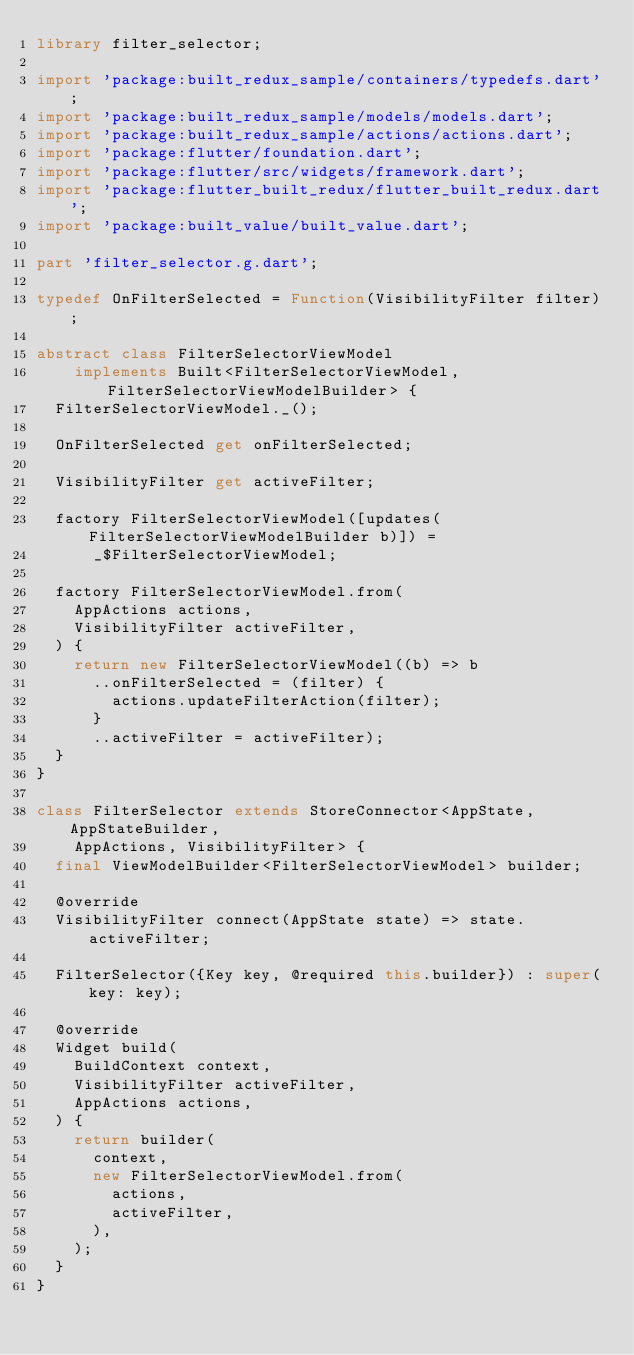<code> <loc_0><loc_0><loc_500><loc_500><_Dart_>library filter_selector;

import 'package:built_redux_sample/containers/typedefs.dart';
import 'package:built_redux_sample/models/models.dart';
import 'package:built_redux_sample/actions/actions.dart';
import 'package:flutter/foundation.dart';
import 'package:flutter/src/widgets/framework.dart';
import 'package:flutter_built_redux/flutter_built_redux.dart';
import 'package:built_value/built_value.dart';

part 'filter_selector.g.dart';

typedef OnFilterSelected = Function(VisibilityFilter filter);

abstract class FilterSelectorViewModel
    implements Built<FilterSelectorViewModel, FilterSelectorViewModelBuilder> {
  FilterSelectorViewModel._();

  OnFilterSelected get onFilterSelected;

  VisibilityFilter get activeFilter;

  factory FilterSelectorViewModel([updates(FilterSelectorViewModelBuilder b)]) =
      _$FilterSelectorViewModel;

  factory FilterSelectorViewModel.from(
    AppActions actions,
    VisibilityFilter activeFilter,
  ) {
    return new FilterSelectorViewModel((b) => b
      ..onFilterSelected = (filter) {
        actions.updateFilterAction(filter);
      }
      ..activeFilter = activeFilter);
  }
}

class FilterSelector extends StoreConnector<AppState, AppStateBuilder,
    AppActions, VisibilityFilter> {
  final ViewModelBuilder<FilterSelectorViewModel> builder;

  @override
  VisibilityFilter connect(AppState state) => state.activeFilter;

  FilterSelector({Key key, @required this.builder}) : super(key: key);

  @override
  Widget build(
    BuildContext context,
    VisibilityFilter activeFilter,
    AppActions actions,
  ) {
    return builder(
      context,
      new FilterSelectorViewModel.from(
        actions,
        activeFilter,
      ),
    );
  }
}
</code> 